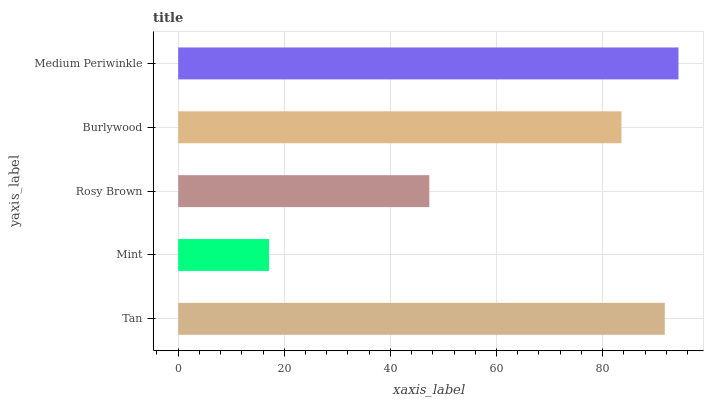Is Mint the minimum?
Answer yes or no. Yes. Is Medium Periwinkle the maximum?
Answer yes or no. Yes. Is Rosy Brown the minimum?
Answer yes or no. No. Is Rosy Brown the maximum?
Answer yes or no. No. Is Rosy Brown greater than Mint?
Answer yes or no. Yes. Is Mint less than Rosy Brown?
Answer yes or no. Yes. Is Mint greater than Rosy Brown?
Answer yes or no. No. Is Rosy Brown less than Mint?
Answer yes or no. No. Is Burlywood the high median?
Answer yes or no. Yes. Is Burlywood the low median?
Answer yes or no. Yes. Is Tan the high median?
Answer yes or no. No. Is Rosy Brown the low median?
Answer yes or no. No. 